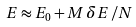<formula> <loc_0><loc_0><loc_500><loc_500>E \approx E _ { 0 } + M \, \delta E \, / N</formula> 